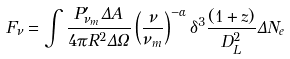<formula> <loc_0><loc_0><loc_500><loc_500>F _ { \nu } = \int \frac { P ^ { \prime } _ { \nu _ { m } } \Delta A } { 4 \pi R ^ { 2 } \Delta \Omega } \left ( \frac { \nu } { \nu _ { m } } \right ) ^ { - \alpha } \delta ^ { 3 } \frac { ( 1 + z ) } { D _ { L } ^ { 2 } } \Delta N _ { e }</formula> 